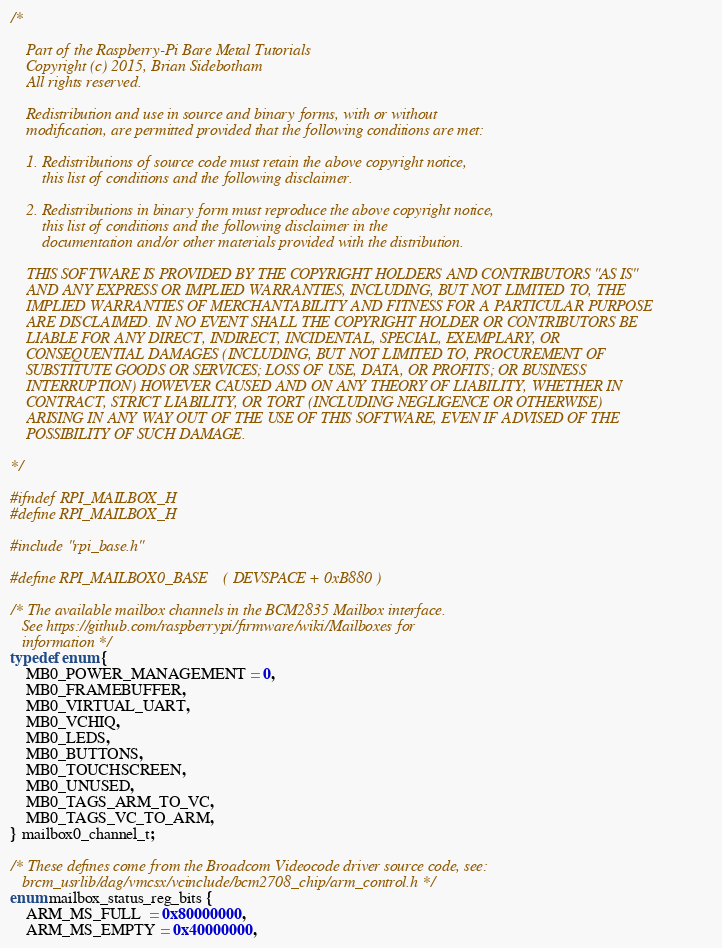<code> <loc_0><loc_0><loc_500><loc_500><_C_>/*

    Part of the Raspberry-Pi Bare Metal Tutorials
    Copyright (c) 2015, Brian Sidebotham
    All rights reserved.

    Redistribution and use in source and binary forms, with or without
    modification, are permitted provided that the following conditions are met:

    1. Redistributions of source code must retain the above copyright notice,
        this list of conditions and the following disclaimer.

    2. Redistributions in binary form must reproduce the above copyright notice,
        this list of conditions and the following disclaimer in the
        documentation and/or other materials provided with the distribution.

    THIS SOFTWARE IS PROVIDED BY THE COPYRIGHT HOLDERS AND CONTRIBUTORS "AS IS"
    AND ANY EXPRESS OR IMPLIED WARRANTIES, INCLUDING, BUT NOT LIMITED TO, THE
    IMPLIED WARRANTIES OF MERCHANTABILITY AND FITNESS FOR A PARTICULAR PURPOSE
    ARE DISCLAIMED. IN NO EVENT SHALL THE COPYRIGHT HOLDER OR CONTRIBUTORS BE
    LIABLE FOR ANY DIRECT, INDIRECT, INCIDENTAL, SPECIAL, EXEMPLARY, OR
    CONSEQUENTIAL DAMAGES (INCLUDING, BUT NOT LIMITED TO, PROCUREMENT OF
    SUBSTITUTE GOODS OR SERVICES; LOSS OF USE, DATA, OR PROFITS; OR BUSINESS
    INTERRUPTION) HOWEVER CAUSED AND ON ANY THEORY OF LIABILITY, WHETHER IN
    CONTRACT, STRICT LIABILITY, OR TORT (INCLUDING NEGLIGENCE OR OTHERWISE)
    ARISING IN ANY WAY OUT OF THE USE OF THIS SOFTWARE, EVEN IF ADVISED OF THE
    POSSIBILITY OF SUCH DAMAGE.

*/

#ifndef RPI_MAILBOX_H
#define RPI_MAILBOX_H

#include "rpi_base.h"

#define RPI_MAILBOX0_BASE    ( DEVSPACE + 0xB880 )

/* The available mailbox channels in the BCM2835 Mailbox interface.
   See https://github.com/raspberrypi/firmware/wiki/Mailboxes for
   information */
typedef enum {
    MB0_POWER_MANAGEMENT = 0,
    MB0_FRAMEBUFFER,
    MB0_VIRTUAL_UART,
    MB0_VCHIQ,
    MB0_LEDS,
    MB0_BUTTONS,
    MB0_TOUCHSCREEN,
    MB0_UNUSED,
    MB0_TAGS_ARM_TO_VC,
    MB0_TAGS_VC_TO_ARM,
} mailbox0_channel_t;

/* These defines come from the Broadcom Videocode driver source code, see:
   brcm_usrlib/dag/vmcsx/vcinclude/bcm2708_chip/arm_control.h */
enum mailbox_status_reg_bits {
    ARM_MS_FULL  = 0x80000000,
    ARM_MS_EMPTY = 0x40000000,</code> 